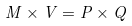<formula> <loc_0><loc_0><loc_500><loc_500>M \times V = P \times Q</formula> 